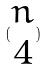<formula> <loc_0><loc_0><loc_500><loc_500>( \begin{matrix} n \\ 4 \end{matrix} )</formula> 